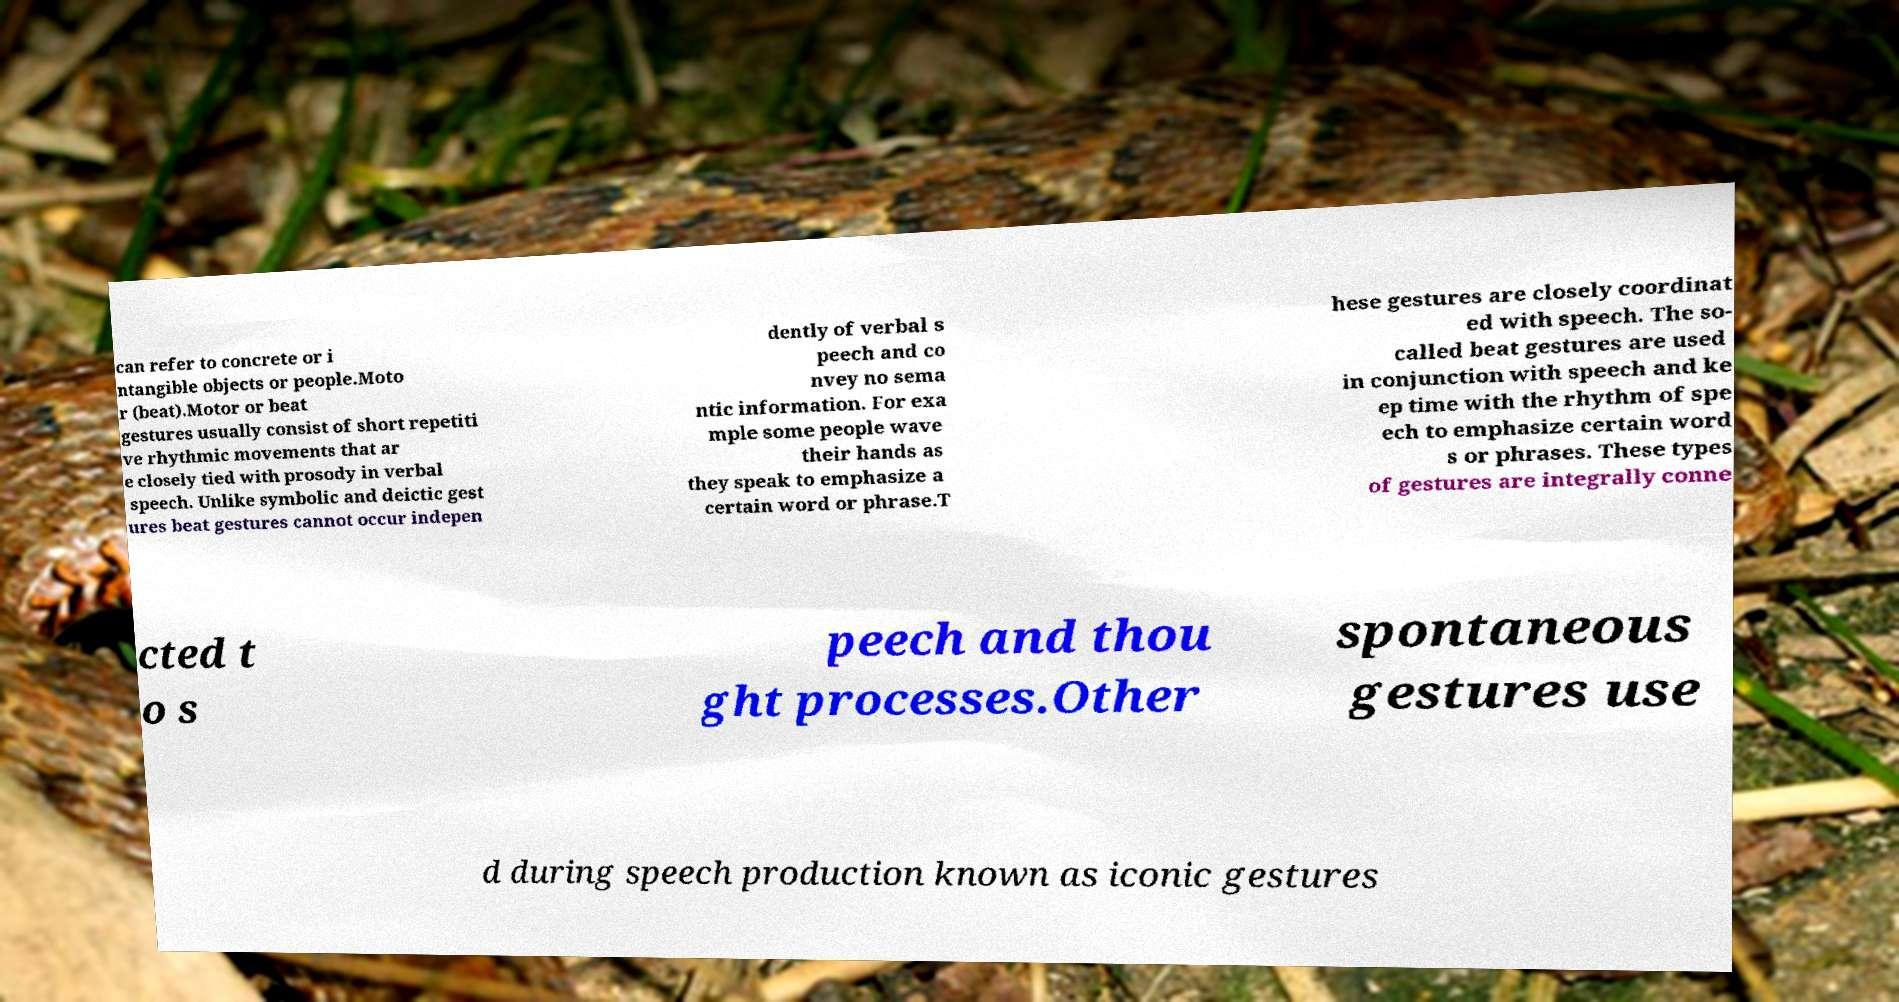I need the written content from this picture converted into text. Can you do that? can refer to concrete or i ntangible objects or people.Moto r (beat).Motor or beat gestures usually consist of short repetiti ve rhythmic movements that ar e closely tied with prosody in verbal speech. Unlike symbolic and deictic gest ures beat gestures cannot occur indepen dently of verbal s peech and co nvey no sema ntic information. For exa mple some people wave their hands as they speak to emphasize a certain word or phrase.T hese gestures are closely coordinat ed with speech. The so- called beat gestures are used in conjunction with speech and ke ep time with the rhythm of spe ech to emphasize certain word s or phrases. These types of gestures are integrally conne cted t o s peech and thou ght processes.Other spontaneous gestures use d during speech production known as iconic gestures 